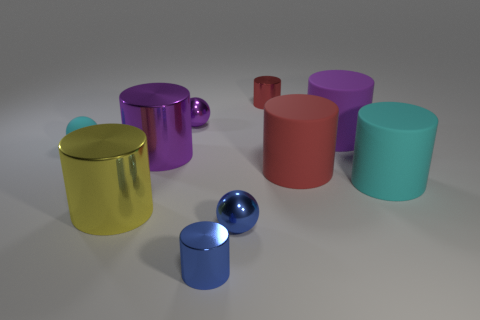Can you tell me what colors the spherical objects are? Certainly, there are two spherical objects: one is blue while the other is purple. 